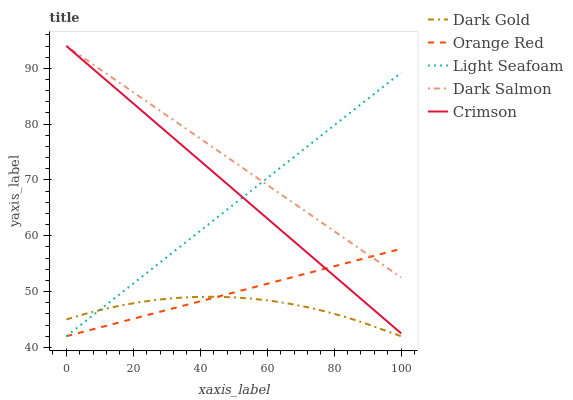Does Dark Gold have the minimum area under the curve?
Answer yes or no. Yes. Does Dark Salmon have the maximum area under the curve?
Answer yes or no. Yes. Does Light Seafoam have the minimum area under the curve?
Answer yes or no. No. Does Light Seafoam have the maximum area under the curve?
Answer yes or no. No. Is Crimson the smoothest?
Answer yes or no. Yes. Is Dark Gold the roughest?
Answer yes or no. Yes. Is Light Seafoam the smoothest?
Answer yes or no. No. Is Light Seafoam the roughest?
Answer yes or no. No. Does Light Seafoam have the lowest value?
Answer yes or no. Yes. Does Dark Salmon have the lowest value?
Answer yes or no. No. Does Dark Salmon have the highest value?
Answer yes or no. Yes. Does Light Seafoam have the highest value?
Answer yes or no. No. Is Dark Gold less than Crimson?
Answer yes or no. Yes. Is Dark Salmon greater than Dark Gold?
Answer yes or no. Yes. Does Dark Salmon intersect Orange Red?
Answer yes or no. Yes. Is Dark Salmon less than Orange Red?
Answer yes or no. No. Is Dark Salmon greater than Orange Red?
Answer yes or no. No. Does Dark Gold intersect Crimson?
Answer yes or no. No. 